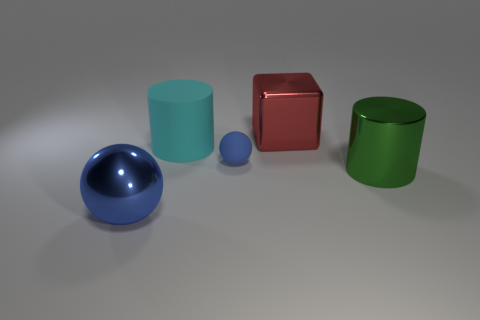What is the shape of the big object that is behind the green thing and to the left of the red shiny object?
Your answer should be compact. Cylinder. There is a ball behind the metallic thing that is in front of the thing right of the big red metal thing; what is its color?
Offer a terse response. Blue. Are there fewer tiny blue matte spheres that are to the left of the big blue metal thing than big objects?
Your answer should be very brief. Yes. There is a blue thing to the right of the cyan cylinder; is its shape the same as the large metallic thing in front of the big green cylinder?
Ensure brevity in your answer.  Yes. How many things are spheres that are to the right of the big cyan matte cylinder or green spheres?
Your response must be concise. 1. What is the material of the big object that is the same color as the small sphere?
Offer a very short reply. Metal. Is there a green shiny thing that is in front of the sphere on the left side of the blue thing behind the big blue metallic thing?
Ensure brevity in your answer.  No. Is the number of big metal objects that are right of the tiny blue thing less than the number of small matte objects in front of the large green shiny object?
Give a very brief answer. No. There is a large cylinder that is the same material as the cube; what color is it?
Provide a succinct answer. Green. What color is the rubber thing that is behind the blue thing to the right of the cyan rubber cylinder?
Offer a terse response. Cyan. 